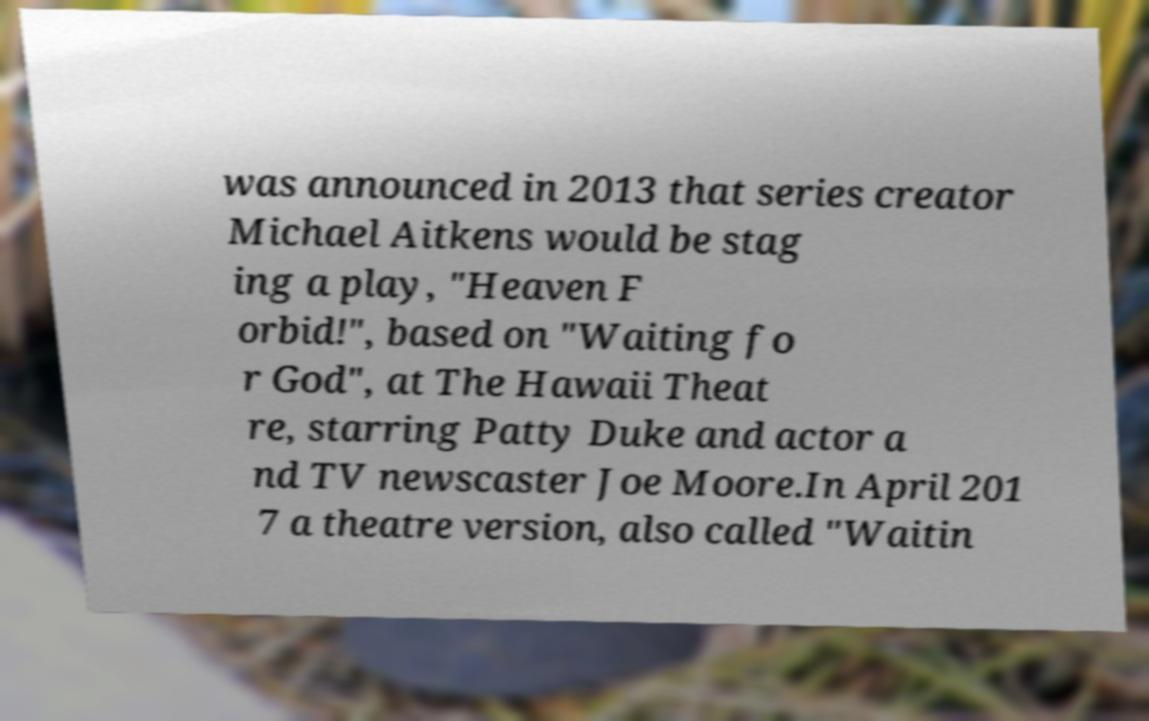Could you assist in decoding the text presented in this image and type it out clearly? was announced in 2013 that series creator Michael Aitkens would be stag ing a play, "Heaven F orbid!", based on "Waiting fo r God", at The Hawaii Theat re, starring Patty Duke and actor a nd TV newscaster Joe Moore.In April 201 7 a theatre version, also called "Waitin 